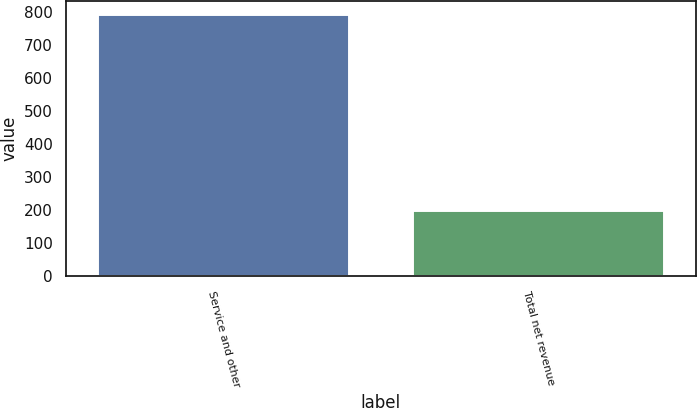<chart> <loc_0><loc_0><loc_500><loc_500><bar_chart><fcel>Service and other<fcel>Total net revenue<nl><fcel>793<fcel>200<nl></chart> 